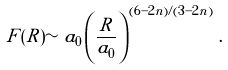<formula> <loc_0><loc_0><loc_500><loc_500>F ( R ) \sim a _ { 0 } \left ( \frac { R } { a _ { 0 } } \right ) ^ { ( 6 - 2 n ) / ( 3 - 2 n ) } \, .</formula> 